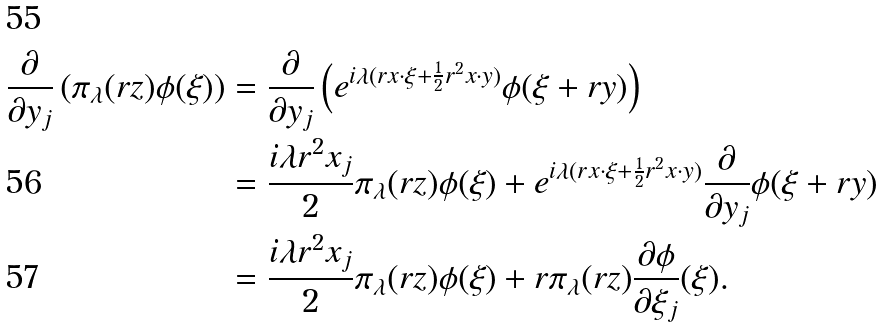<formula> <loc_0><loc_0><loc_500><loc_500>\frac { \partial } { \partial y _ { j } } \left ( \pi _ { \lambda } ( r z ) \phi ( \xi ) \right ) & = \frac { \partial } { \partial y _ { j } } \left ( e ^ { i \lambda ( r x \cdot \xi + \frac { 1 } { 2 } r ^ { 2 } x \cdot y ) } \phi ( \xi + r y ) \right ) \\ & = \frac { i \lambda r ^ { 2 } x _ { j } } { 2 } \pi _ { \lambda } ( r z ) \phi ( \xi ) + e ^ { i \lambda ( r x \cdot \xi + \frac { 1 } { 2 } r ^ { 2 } x \cdot y ) } \frac { \partial } { \partial y _ { j } } \phi ( \xi + r y ) \\ & = \frac { i \lambda r ^ { 2 } x _ { j } } { 2 } \pi _ { \lambda } ( r z ) \phi ( \xi ) + r \pi _ { \lambda } ( r z ) \frac { \partial \phi } { \partial \xi _ { j } } ( \xi ) .</formula> 